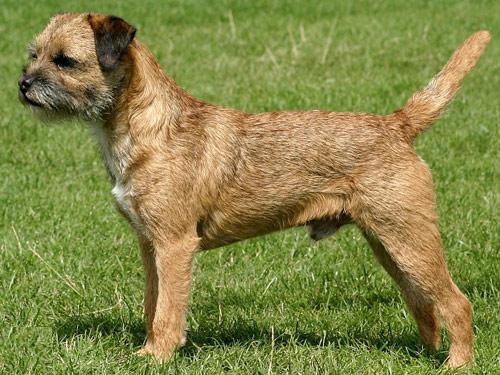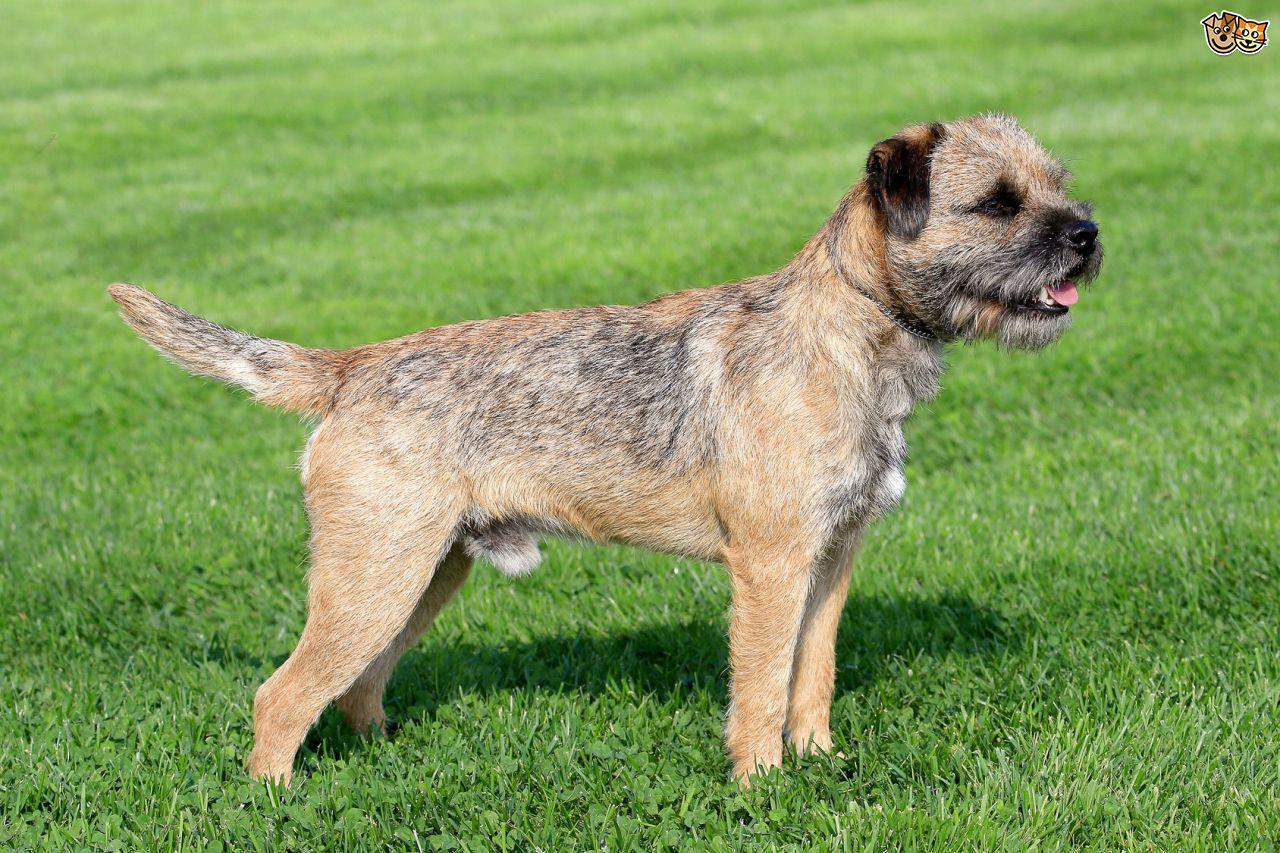The first image is the image on the left, the second image is the image on the right. Analyze the images presented: Is the assertion "The dog on each image is facing the opposite direction of where the other is facing." valid? Answer yes or no. Yes. 